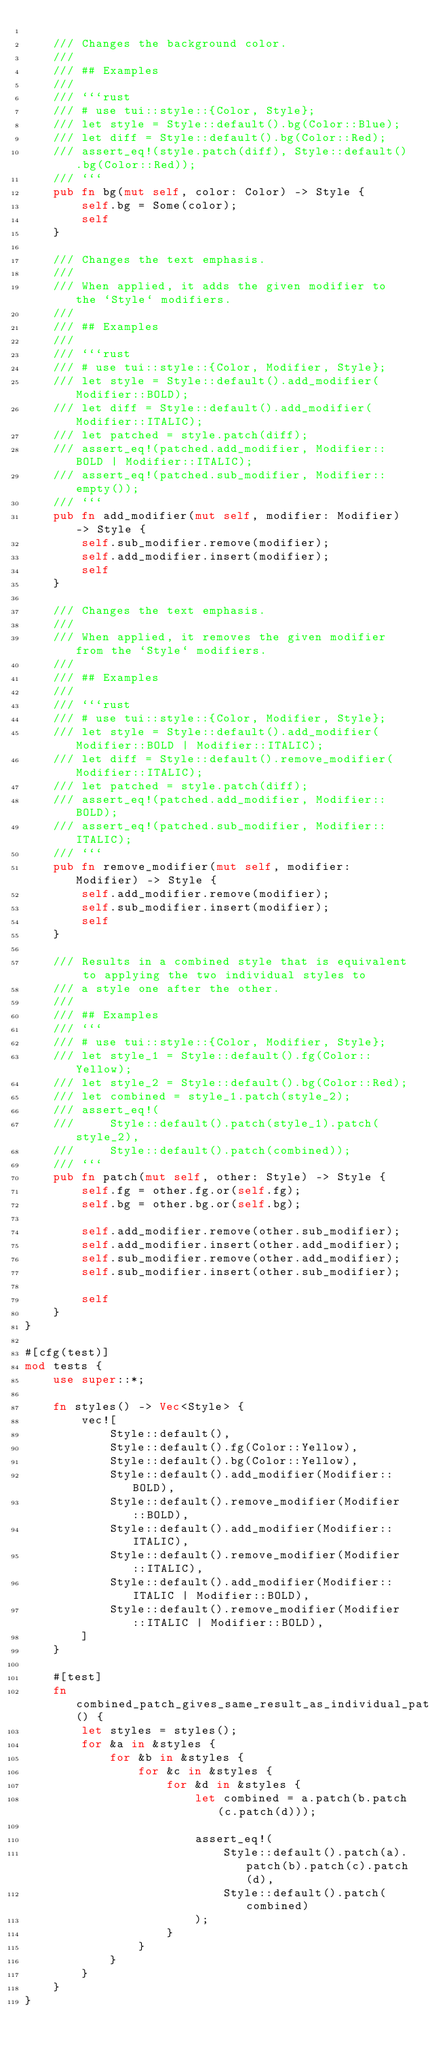Convert code to text. <code><loc_0><loc_0><loc_500><loc_500><_Rust_>
    /// Changes the background color.
    ///
    /// ## Examples
    ///
    /// ```rust
    /// # use tui::style::{Color, Style};
    /// let style = Style::default().bg(Color::Blue);
    /// let diff = Style::default().bg(Color::Red);
    /// assert_eq!(style.patch(diff), Style::default().bg(Color::Red));
    /// ```
    pub fn bg(mut self, color: Color) -> Style {
        self.bg = Some(color);
        self
    }

    /// Changes the text emphasis.
    ///
    /// When applied, it adds the given modifier to the `Style` modifiers.
    ///
    /// ## Examples
    ///
    /// ```rust
    /// # use tui::style::{Color, Modifier, Style};
    /// let style = Style::default().add_modifier(Modifier::BOLD);
    /// let diff = Style::default().add_modifier(Modifier::ITALIC);
    /// let patched = style.patch(diff);
    /// assert_eq!(patched.add_modifier, Modifier::BOLD | Modifier::ITALIC);
    /// assert_eq!(patched.sub_modifier, Modifier::empty());
    /// ```
    pub fn add_modifier(mut self, modifier: Modifier) -> Style {
        self.sub_modifier.remove(modifier);
        self.add_modifier.insert(modifier);
        self
    }

    /// Changes the text emphasis.
    ///
    /// When applied, it removes the given modifier from the `Style` modifiers.
    ///
    /// ## Examples
    ///
    /// ```rust
    /// # use tui::style::{Color, Modifier, Style};
    /// let style = Style::default().add_modifier(Modifier::BOLD | Modifier::ITALIC);
    /// let diff = Style::default().remove_modifier(Modifier::ITALIC);
    /// let patched = style.patch(diff);
    /// assert_eq!(patched.add_modifier, Modifier::BOLD);
    /// assert_eq!(patched.sub_modifier, Modifier::ITALIC);
    /// ```
    pub fn remove_modifier(mut self, modifier: Modifier) -> Style {
        self.add_modifier.remove(modifier);
        self.sub_modifier.insert(modifier);
        self
    }

    /// Results in a combined style that is equivalent to applying the two individual styles to
    /// a style one after the other.
    ///
    /// ## Examples
    /// ```
    /// # use tui::style::{Color, Modifier, Style};
    /// let style_1 = Style::default().fg(Color::Yellow);
    /// let style_2 = Style::default().bg(Color::Red);
    /// let combined = style_1.patch(style_2);
    /// assert_eq!(
    ///     Style::default().patch(style_1).patch(style_2),
    ///     Style::default().patch(combined));
    /// ```
    pub fn patch(mut self, other: Style) -> Style {
        self.fg = other.fg.or(self.fg);
        self.bg = other.bg.or(self.bg);

        self.add_modifier.remove(other.sub_modifier);
        self.add_modifier.insert(other.add_modifier);
        self.sub_modifier.remove(other.add_modifier);
        self.sub_modifier.insert(other.sub_modifier);

        self
    }
}

#[cfg(test)]
mod tests {
    use super::*;

    fn styles() -> Vec<Style> {
        vec![
            Style::default(),
            Style::default().fg(Color::Yellow),
            Style::default().bg(Color::Yellow),
            Style::default().add_modifier(Modifier::BOLD),
            Style::default().remove_modifier(Modifier::BOLD),
            Style::default().add_modifier(Modifier::ITALIC),
            Style::default().remove_modifier(Modifier::ITALIC),
            Style::default().add_modifier(Modifier::ITALIC | Modifier::BOLD),
            Style::default().remove_modifier(Modifier::ITALIC | Modifier::BOLD),
        ]
    }

    #[test]
    fn combined_patch_gives_same_result_as_individual_patch() {
        let styles = styles();
        for &a in &styles {
            for &b in &styles {
                for &c in &styles {
                    for &d in &styles {
                        let combined = a.patch(b.patch(c.patch(d)));

                        assert_eq!(
                            Style::default().patch(a).patch(b).patch(c).patch(d),
                            Style::default().patch(combined)
                        );
                    }
                }
            }
        }
    }
}
</code> 